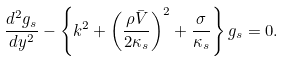<formula> <loc_0><loc_0><loc_500><loc_500>\frac { d ^ { 2 } g _ { s } } { d y ^ { 2 } } - \left \{ k ^ { 2 } + \left ( \frac { \rho \bar { V } } { 2 \kappa _ { s } } \right ) ^ { 2 } + \frac { \sigma } { \kappa _ { s } } \right \} g _ { s } = 0 .</formula> 